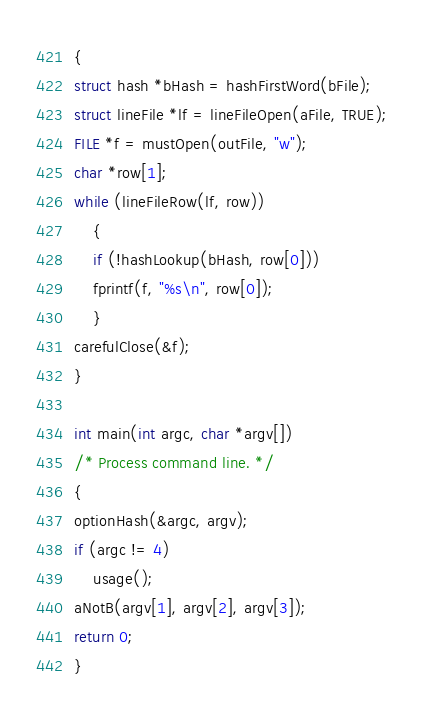Convert code to text. <code><loc_0><loc_0><loc_500><loc_500><_C_>{
struct hash *bHash = hashFirstWord(bFile);
struct lineFile *lf = lineFileOpen(aFile, TRUE);
FILE *f = mustOpen(outFile, "w");
char *row[1];
while (lineFileRow(lf, row))
    {
    if (!hashLookup(bHash, row[0]))
	fprintf(f, "%s\n", row[0]);
    }
carefulClose(&f);
}

int main(int argc, char *argv[])
/* Process command line. */
{
optionHash(&argc, argv);
if (argc != 4)
    usage();
aNotB(argv[1], argv[2], argv[3]);
return 0;
}
</code> 